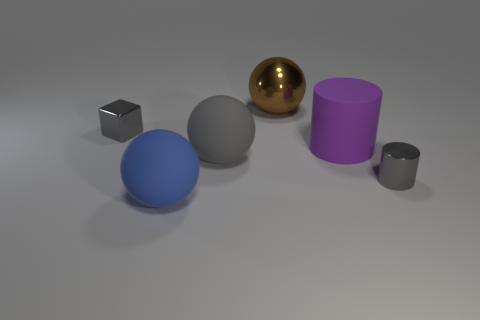Add 1 big balls. How many objects exist? 7 Subtract all cylinders. How many objects are left? 4 Subtract all tiny blue cylinders. Subtract all rubber cylinders. How many objects are left? 5 Add 5 gray cubes. How many gray cubes are left? 6 Add 6 metallic cubes. How many metallic cubes exist? 7 Subtract 0 cyan blocks. How many objects are left? 6 